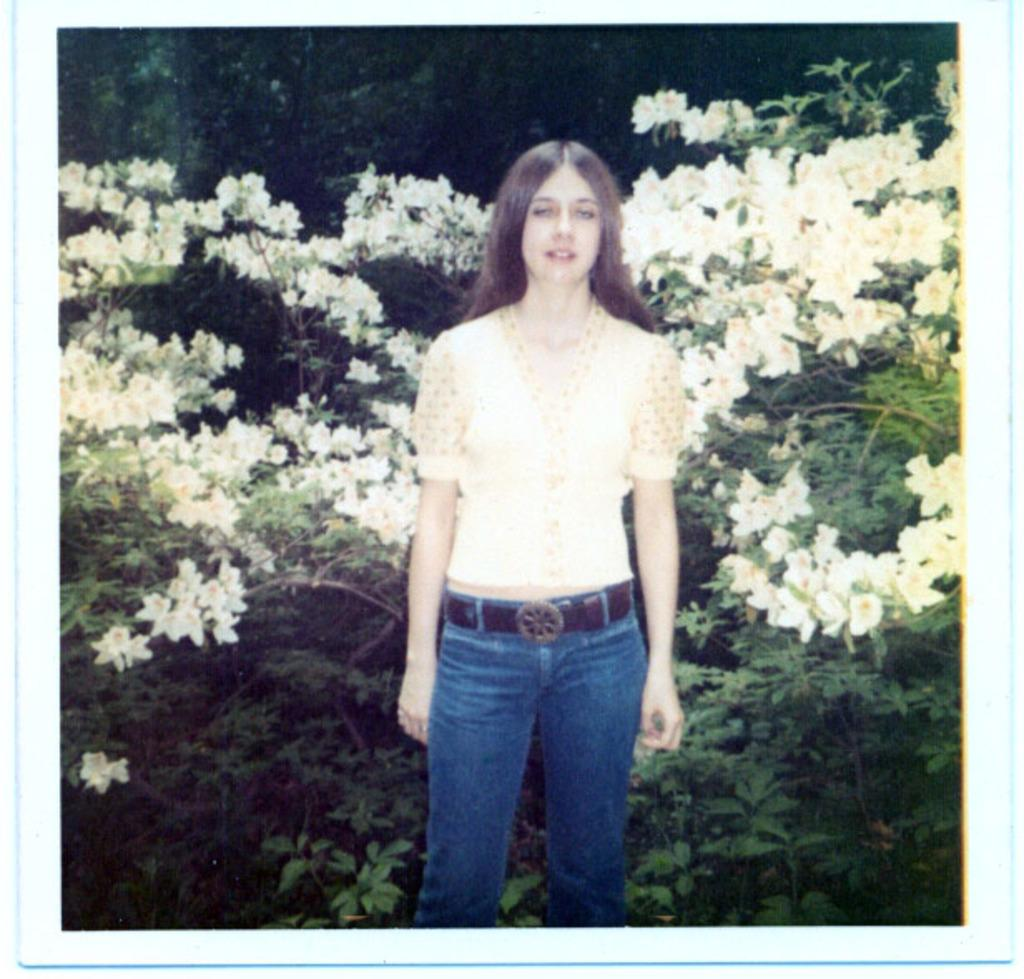What is the main subject of the image? There is a woman standing in the image. What can be seen in the background of the image? Flower plants and trees are present in the background of the image. How many jellyfish are swimming in the image? There are no jellyfish present in the image; it features a woman standing and flower plants and trees in the background. What is the distance between the woman and the trees in the image? The provided facts do not give information about the distance between the woman and the trees, so it cannot be determined from the image. 